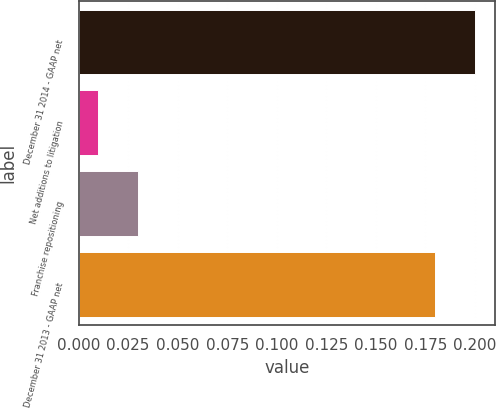<chart> <loc_0><loc_0><loc_500><loc_500><bar_chart><fcel>December 31 2014 - GAAP net<fcel>Net additions to litigation<fcel>Franchise repositioning<fcel>December 31 2013 - GAAP net<nl><fcel>0.2<fcel>0.01<fcel>0.03<fcel>0.18<nl></chart> 